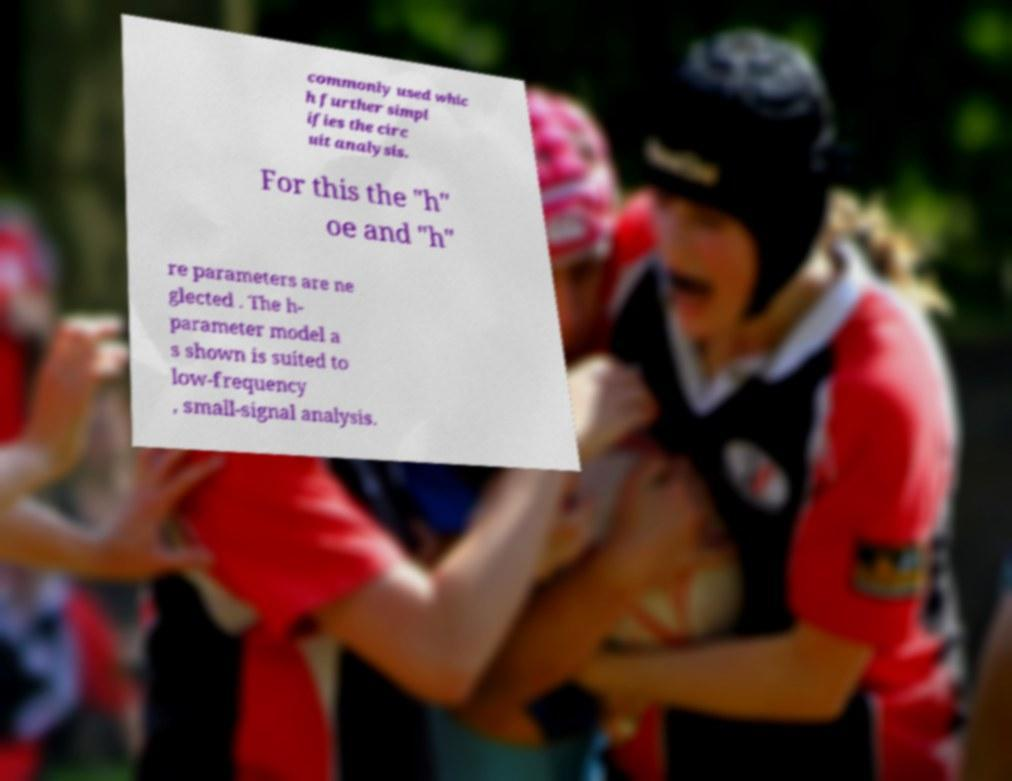I need the written content from this picture converted into text. Can you do that? commonly used whic h further simpl ifies the circ uit analysis. For this the "h" oe and "h" re parameters are ne glected . The h- parameter model a s shown is suited to low-frequency , small-signal analysis. 